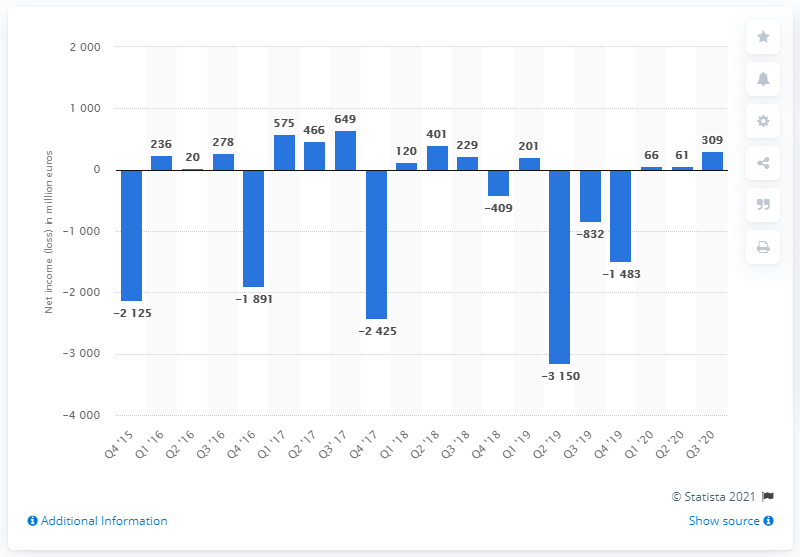List a handful of essential elements in this visual. The net income of Deutsche Bank in the third quarter of 2020 was 309 million dollars. 